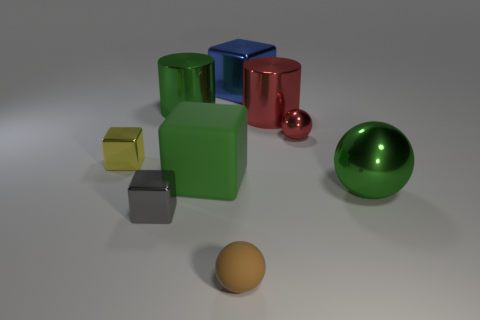Add 1 big green rubber cubes. How many objects exist? 10 Subtract all balls. How many objects are left? 6 Add 6 tiny gray things. How many tiny gray things exist? 7 Subtract 0 blue cylinders. How many objects are left? 9 Subtract all brown matte things. Subtract all shiny things. How many objects are left? 1 Add 9 tiny gray shiny blocks. How many tiny gray shiny blocks are left? 10 